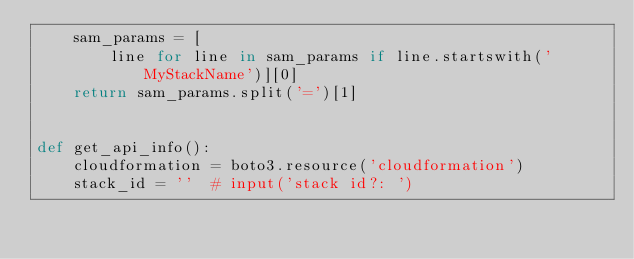Convert code to text. <code><loc_0><loc_0><loc_500><loc_500><_Python_>    sam_params = [
        line for line in sam_params if line.startswith('MyStackName')][0]
    return sam_params.split('=')[1]


def get_api_info():
    cloudformation = boto3.resource('cloudformation')
    stack_id = ''  # input('stack id?: ')</code> 